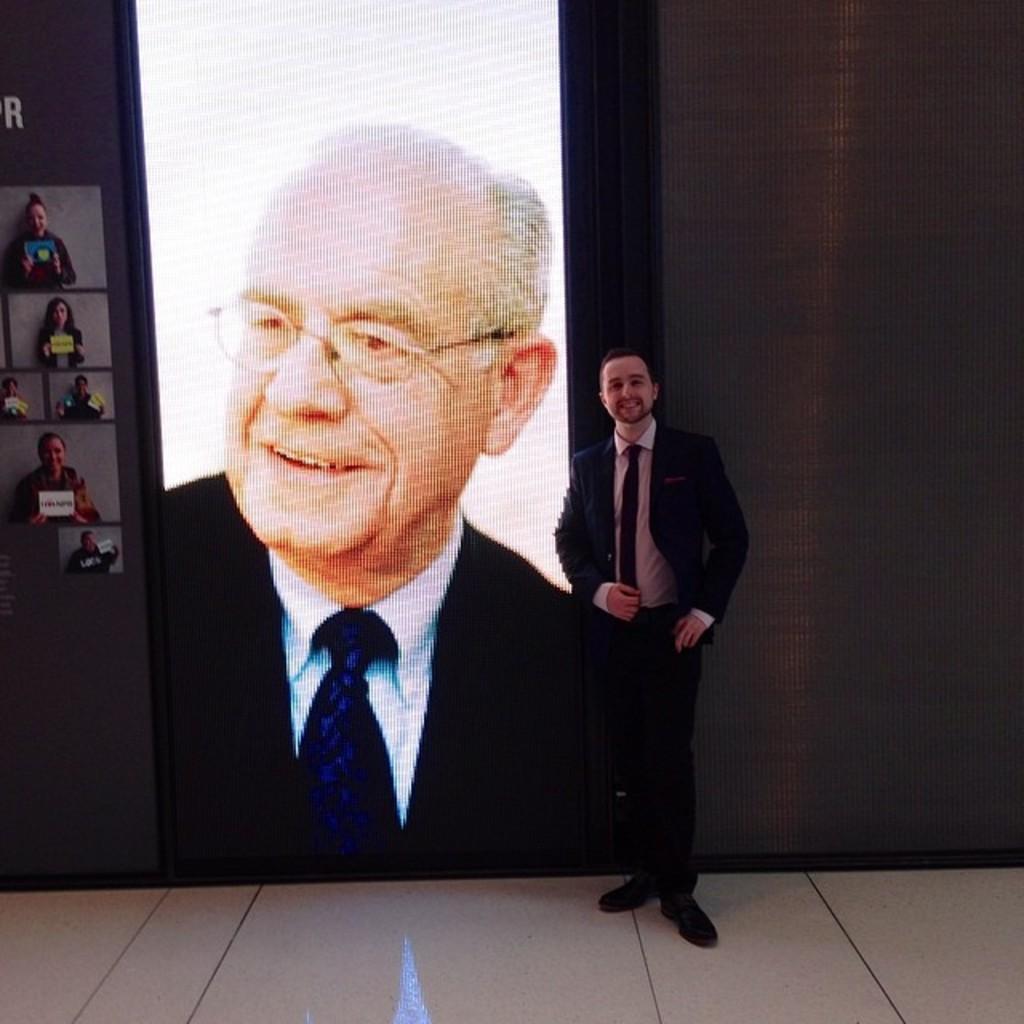Describe this image in one or two sentences. In this image we can see a person standing on the floor. On the backside we can see a picture of a person on a wall. On the left side we can see some pictures of people holding boards. 